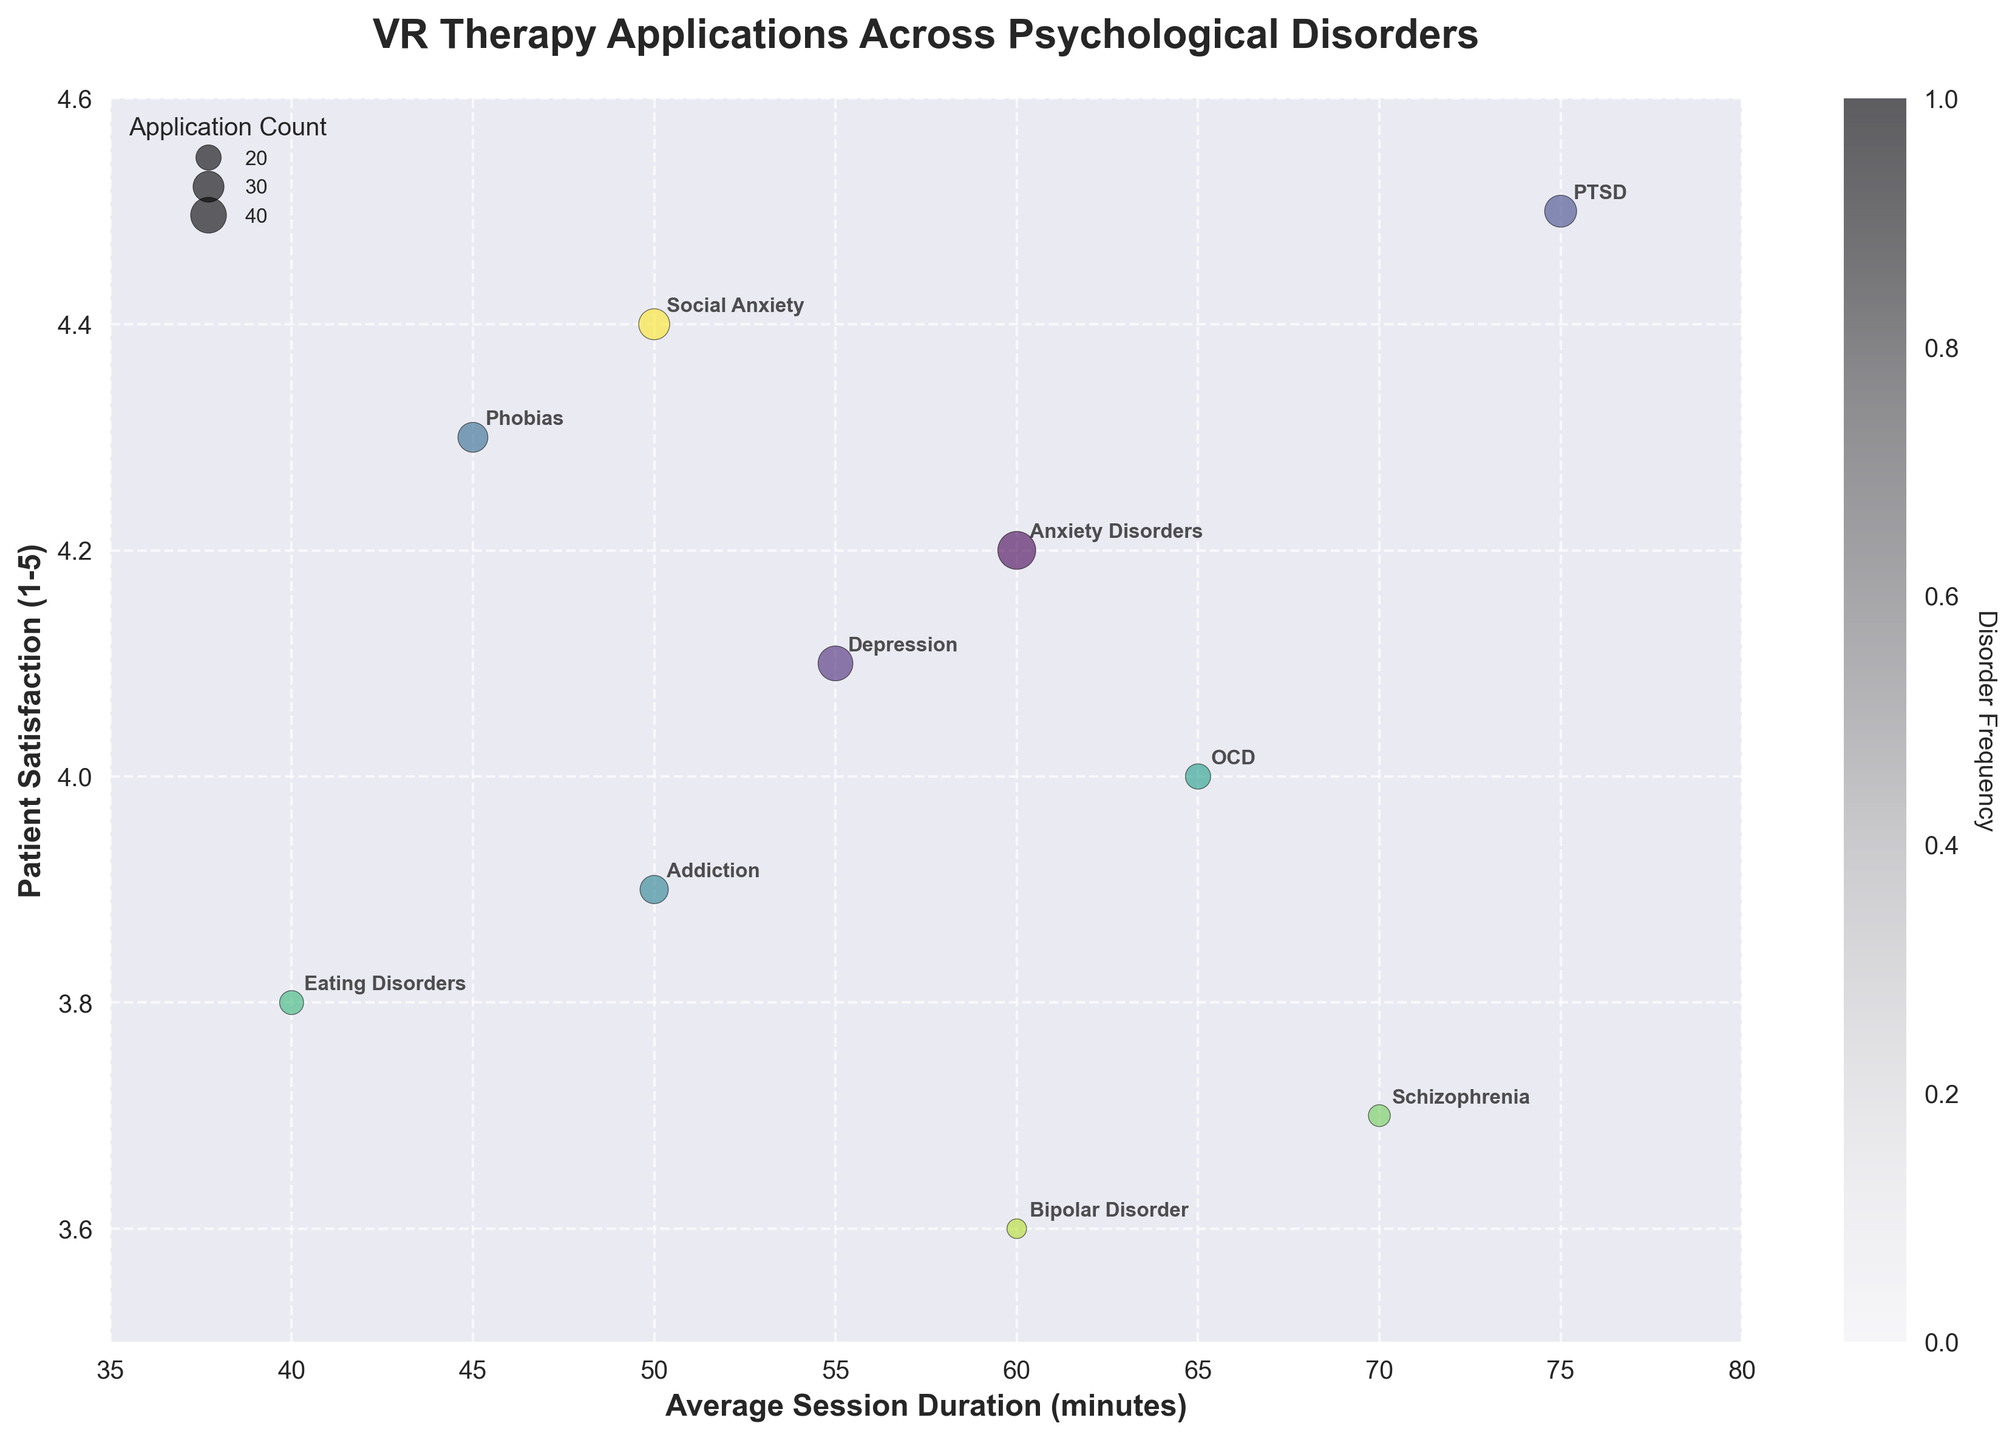What's the title of the figure? The title is usually found at the top of the figure.
Answer: VR Therapy Applications Across Psychological Disorders What does the x-axis represent? The x-axis label indicates that it represents average session duration in minutes.
Answer: Average Session Duration (minutes) Which psychological disorder has the highest patient satisfaction? By looking at the y-axis and the bubble positioned at the highest point on that axis, PTSD has the highest patient satisfaction of 4.5.
Answer: PTSD What is the average session duration for Schizophrenia? You can find Schizophrenia labeled on the chart, and it corresponds to an average session duration of 70 minutes.
Answer: 70 minutes Which disorder has the largest bubble size? Bubble size represents the number of applications. By visual inspection, Anxiety Disorders have the largest bubble size, corresponding to 45 applications.
Answer: Anxiety Disorders How many psychological disorders have an average session duration greater than 60 minutes? By counting the bubbles positioned to the right of the 60-minute mark on the x-axis, three disorders meet this criterion: Anxiety Disorders, OCD, and Schizophrenia.
Answer: 3 Which disorder has higher patient satisfaction: Social Anxiety or Addiction? By comparing the y-axis positions of Social Anxiety and Addiction bubbles, Social Anxiety (4.4) has a higher patient satisfaction than Addiction (3.9).
Answer: Social Anxiety What is the range of average session durations in the figure? The smallest average session duration is for Eating Disorders (40 minutes), and the largest is for PTSD (75 minutes), giving a range of 75 - 40 = 35 minutes.
Answer: 35 minutes Compare the patient satisfaction levels between Depression and Phobias. Which is higher and by how much? Depression has a patient satisfaction of 4.1, and Phobias have 4.3. The difference is 4.3 - 4.1 = 0.2.
Answer: Phobias by 0.2 What is the average patient satisfaction across all disorders? By summing up all satisfaction values (4.2+4.1+4.5+4.3+3.9+4.0+3.8+3.7+3.6+4.4) and dividing by the number of disorders (10), the average is 40.5 / 10 = 4.05.
Answer: 4.05 How does the number of VR therapy applications for Eating Disorders compare to that for Bipolar Disorder? Eating Disorders have 18 applications, while Bipolar Disorder has 12, hence Eating Disorders have 6 more applications.
Answer: Eating Disorders by 6 